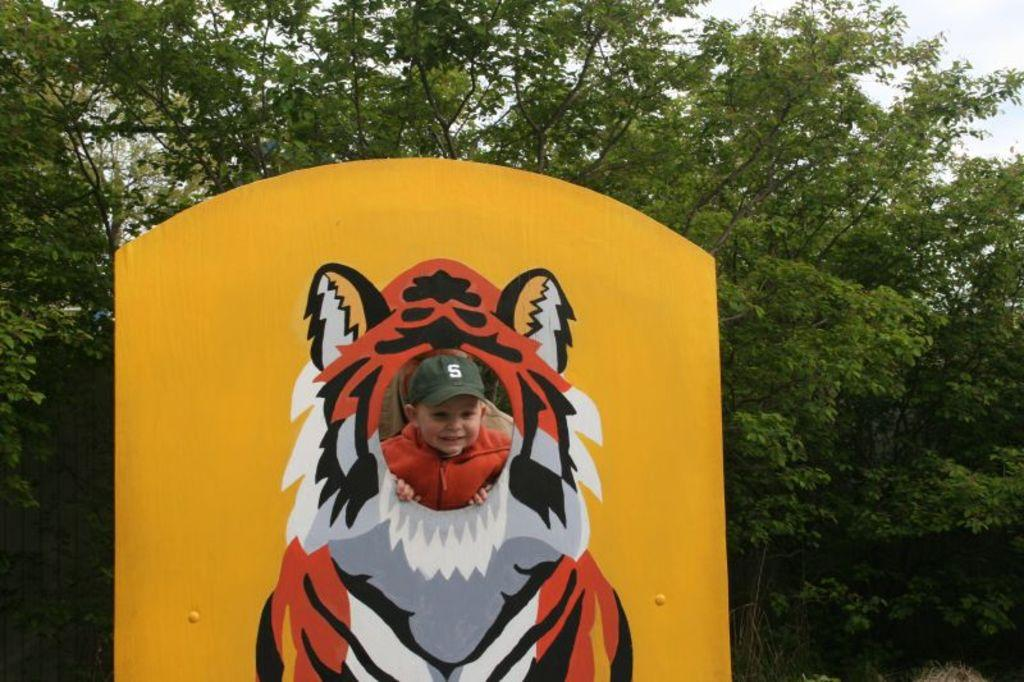What is depicted on the board in the image? There is a drawing of a tiger on the board in the image. Where is the drawing located in relation to the image? The drawing is at the bottom of the image. What can be seen in the middle of the image? There is a child in the middle of the image. What is visible in the background of the image? There are trees in the background of the image. What type of club does the child use to interact with the tiger drawing? There is no club present in the image, and the child is not interacting with the tiger drawing. How many spoons are visible in the image? There are no spoons visible in the image. 